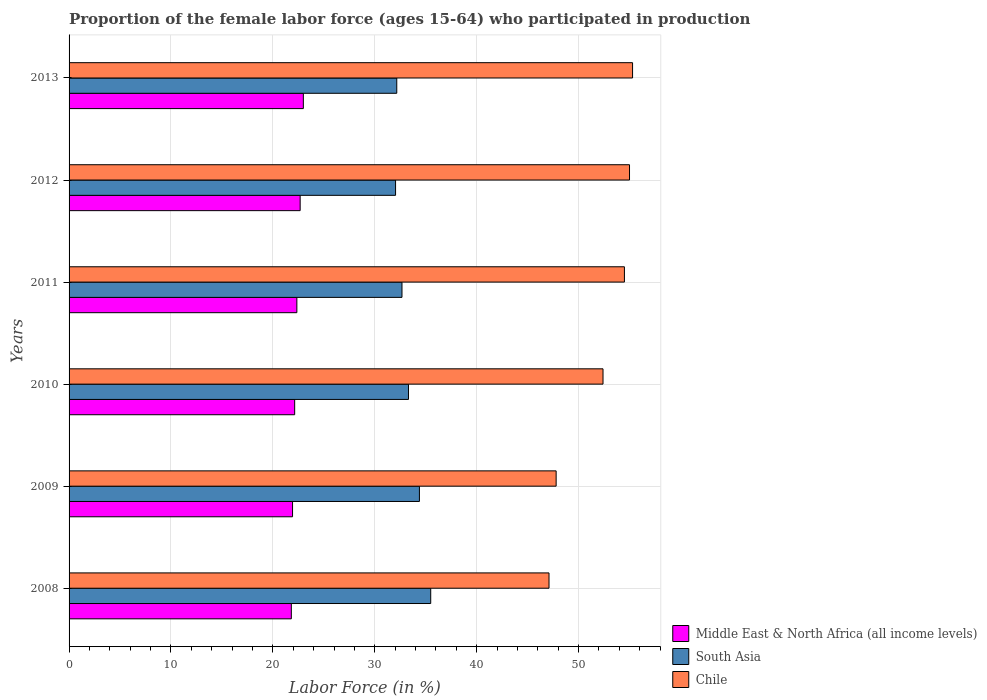How many bars are there on the 6th tick from the bottom?
Give a very brief answer. 3. What is the label of the 5th group of bars from the top?
Your answer should be compact. 2009. What is the proportion of the female labor force who participated in production in South Asia in 2010?
Provide a short and direct response. 33.31. Across all years, what is the maximum proportion of the female labor force who participated in production in South Asia?
Offer a very short reply. 35.49. Across all years, what is the minimum proportion of the female labor force who participated in production in Middle East & North Africa (all income levels)?
Your response must be concise. 21.81. In which year was the proportion of the female labor force who participated in production in Middle East & North Africa (all income levels) minimum?
Give a very brief answer. 2008. What is the total proportion of the female labor force who participated in production in Chile in the graph?
Give a very brief answer. 312.1. What is the difference between the proportion of the female labor force who participated in production in Chile in 2010 and that in 2013?
Give a very brief answer. -2.9. What is the difference between the proportion of the female labor force who participated in production in Middle East & North Africa (all income levels) in 2010 and the proportion of the female labor force who participated in production in Chile in 2013?
Your response must be concise. -33.16. What is the average proportion of the female labor force who participated in production in Middle East & North Africa (all income levels) per year?
Keep it short and to the point. 22.32. In the year 2013, what is the difference between the proportion of the female labor force who participated in production in South Asia and proportion of the female labor force who participated in production in Chile?
Provide a short and direct response. -23.14. What is the ratio of the proportion of the female labor force who participated in production in Middle East & North Africa (all income levels) in 2009 to that in 2010?
Ensure brevity in your answer.  0.99. Is the proportion of the female labor force who participated in production in Chile in 2010 less than that in 2011?
Make the answer very short. Yes. What is the difference between the highest and the second highest proportion of the female labor force who participated in production in Middle East & North Africa (all income levels)?
Your response must be concise. 0.31. What is the difference between the highest and the lowest proportion of the female labor force who participated in production in Middle East & North Africa (all income levels)?
Provide a succinct answer. 1.18. What does the 3rd bar from the top in 2009 represents?
Your answer should be compact. Middle East & North Africa (all income levels). What does the 3rd bar from the bottom in 2013 represents?
Make the answer very short. Chile. Is it the case that in every year, the sum of the proportion of the female labor force who participated in production in South Asia and proportion of the female labor force who participated in production in Middle East & North Africa (all income levels) is greater than the proportion of the female labor force who participated in production in Chile?
Your answer should be very brief. No. Are all the bars in the graph horizontal?
Make the answer very short. Yes. How many years are there in the graph?
Keep it short and to the point. 6. Are the values on the major ticks of X-axis written in scientific E-notation?
Give a very brief answer. No. Does the graph contain grids?
Make the answer very short. Yes. Where does the legend appear in the graph?
Offer a very short reply. Bottom right. How many legend labels are there?
Ensure brevity in your answer.  3. What is the title of the graph?
Your response must be concise. Proportion of the female labor force (ages 15-64) who participated in production. What is the Labor Force (in %) of Middle East & North Africa (all income levels) in 2008?
Give a very brief answer. 21.81. What is the Labor Force (in %) of South Asia in 2008?
Offer a very short reply. 35.49. What is the Labor Force (in %) in Chile in 2008?
Your response must be concise. 47.1. What is the Labor Force (in %) in Middle East & North Africa (all income levels) in 2009?
Make the answer very short. 21.93. What is the Labor Force (in %) in South Asia in 2009?
Make the answer very short. 34.38. What is the Labor Force (in %) in Chile in 2009?
Keep it short and to the point. 47.8. What is the Labor Force (in %) in Middle East & North Africa (all income levels) in 2010?
Ensure brevity in your answer.  22.14. What is the Labor Force (in %) in South Asia in 2010?
Your answer should be very brief. 33.31. What is the Labor Force (in %) in Chile in 2010?
Provide a short and direct response. 52.4. What is the Labor Force (in %) in Middle East & North Africa (all income levels) in 2011?
Provide a short and direct response. 22.35. What is the Labor Force (in %) of South Asia in 2011?
Your answer should be compact. 32.67. What is the Labor Force (in %) in Chile in 2011?
Your answer should be very brief. 54.5. What is the Labor Force (in %) of Middle East & North Africa (all income levels) in 2012?
Your answer should be very brief. 22.68. What is the Labor Force (in %) in South Asia in 2012?
Make the answer very short. 32.04. What is the Labor Force (in %) in Chile in 2012?
Your answer should be compact. 55. What is the Labor Force (in %) in Middle East & North Africa (all income levels) in 2013?
Provide a short and direct response. 22.99. What is the Labor Force (in %) of South Asia in 2013?
Offer a terse response. 32.16. What is the Labor Force (in %) of Chile in 2013?
Offer a terse response. 55.3. Across all years, what is the maximum Labor Force (in %) of Middle East & North Africa (all income levels)?
Offer a very short reply. 22.99. Across all years, what is the maximum Labor Force (in %) in South Asia?
Offer a very short reply. 35.49. Across all years, what is the maximum Labor Force (in %) in Chile?
Your answer should be very brief. 55.3. Across all years, what is the minimum Labor Force (in %) of Middle East & North Africa (all income levels)?
Your answer should be compact. 21.81. Across all years, what is the minimum Labor Force (in %) of South Asia?
Offer a terse response. 32.04. Across all years, what is the minimum Labor Force (in %) of Chile?
Your answer should be compact. 47.1. What is the total Labor Force (in %) in Middle East & North Africa (all income levels) in the graph?
Your answer should be very brief. 133.91. What is the total Labor Force (in %) in South Asia in the graph?
Ensure brevity in your answer.  200.05. What is the total Labor Force (in %) of Chile in the graph?
Your response must be concise. 312.1. What is the difference between the Labor Force (in %) in Middle East & North Africa (all income levels) in 2008 and that in 2009?
Provide a short and direct response. -0.12. What is the difference between the Labor Force (in %) in South Asia in 2008 and that in 2009?
Keep it short and to the point. 1.11. What is the difference between the Labor Force (in %) of Middle East & North Africa (all income levels) in 2008 and that in 2010?
Your response must be concise. -0.33. What is the difference between the Labor Force (in %) in South Asia in 2008 and that in 2010?
Offer a very short reply. 2.18. What is the difference between the Labor Force (in %) of Middle East & North Africa (all income levels) in 2008 and that in 2011?
Your answer should be very brief. -0.54. What is the difference between the Labor Force (in %) in South Asia in 2008 and that in 2011?
Give a very brief answer. 2.82. What is the difference between the Labor Force (in %) of Chile in 2008 and that in 2011?
Keep it short and to the point. -7.4. What is the difference between the Labor Force (in %) in Middle East & North Africa (all income levels) in 2008 and that in 2012?
Give a very brief answer. -0.87. What is the difference between the Labor Force (in %) in South Asia in 2008 and that in 2012?
Your response must be concise. 3.45. What is the difference between the Labor Force (in %) of Middle East & North Africa (all income levels) in 2008 and that in 2013?
Your answer should be compact. -1.18. What is the difference between the Labor Force (in %) of South Asia in 2008 and that in 2013?
Your answer should be compact. 3.33. What is the difference between the Labor Force (in %) of Middle East & North Africa (all income levels) in 2009 and that in 2010?
Offer a very short reply. -0.21. What is the difference between the Labor Force (in %) in South Asia in 2009 and that in 2010?
Offer a terse response. 1.07. What is the difference between the Labor Force (in %) in Middle East & North Africa (all income levels) in 2009 and that in 2011?
Offer a very short reply. -0.42. What is the difference between the Labor Force (in %) in South Asia in 2009 and that in 2011?
Provide a succinct answer. 1.71. What is the difference between the Labor Force (in %) of Middle East & North Africa (all income levels) in 2009 and that in 2012?
Keep it short and to the point. -0.75. What is the difference between the Labor Force (in %) in South Asia in 2009 and that in 2012?
Give a very brief answer. 2.34. What is the difference between the Labor Force (in %) in Middle East & North Africa (all income levels) in 2009 and that in 2013?
Make the answer very short. -1.06. What is the difference between the Labor Force (in %) of South Asia in 2009 and that in 2013?
Your answer should be very brief. 2.22. What is the difference between the Labor Force (in %) in Middle East & North Africa (all income levels) in 2010 and that in 2011?
Your answer should be compact. -0.21. What is the difference between the Labor Force (in %) of South Asia in 2010 and that in 2011?
Offer a terse response. 0.64. What is the difference between the Labor Force (in %) of Chile in 2010 and that in 2011?
Provide a short and direct response. -2.1. What is the difference between the Labor Force (in %) of Middle East & North Africa (all income levels) in 2010 and that in 2012?
Provide a short and direct response. -0.54. What is the difference between the Labor Force (in %) of South Asia in 2010 and that in 2012?
Ensure brevity in your answer.  1.27. What is the difference between the Labor Force (in %) of Middle East & North Africa (all income levels) in 2010 and that in 2013?
Provide a succinct answer. -0.85. What is the difference between the Labor Force (in %) of South Asia in 2010 and that in 2013?
Your response must be concise. 1.15. What is the difference between the Labor Force (in %) of Chile in 2010 and that in 2013?
Offer a terse response. -2.9. What is the difference between the Labor Force (in %) of Middle East & North Africa (all income levels) in 2011 and that in 2012?
Your answer should be compact. -0.32. What is the difference between the Labor Force (in %) of South Asia in 2011 and that in 2012?
Provide a short and direct response. 0.63. What is the difference between the Labor Force (in %) of Chile in 2011 and that in 2012?
Offer a very short reply. -0.5. What is the difference between the Labor Force (in %) in Middle East & North Africa (all income levels) in 2011 and that in 2013?
Keep it short and to the point. -0.64. What is the difference between the Labor Force (in %) in South Asia in 2011 and that in 2013?
Provide a short and direct response. 0.51. What is the difference between the Labor Force (in %) in Chile in 2011 and that in 2013?
Offer a very short reply. -0.8. What is the difference between the Labor Force (in %) of Middle East & North Africa (all income levels) in 2012 and that in 2013?
Keep it short and to the point. -0.31. What is the difference between the Labor Force (in %) of South Asia in 2012 and that in 2013?
Your answer should be very brief. -0.12. What is the difference between the Labor Force (in %) of Chile in 2012 and that in 2013?
Make the answer very short. -0.3. What is the difference between the Labor Force (in %) of Middle East & North Africa (all income levels) in 2008 and the Labor Force (in %) of South Asia in 2009?
Make the answer very short. -12.57. What is the difference between the Labor Force (in %) in Middle East & North Africa (all income levels) in 2008 and the Labor Force (in %) in Chile in 2009?
Your response must be concise. -25.99. What is the difference between the Labor Force (in %) of South Asia in 2008 and the Labor Force (in %) of Chile in 2009?
Your response must be concise. -12.31. What is the difference between the Labor Force (in %) in Middle East & North Africa (all income levels) in 2008 and the Labor Force (in %) in South Asia in 2010?
Make the answer very short. -11.5. What is the difference between the Labor Force (in %) of Middle East & North Africa (all income levels) in 2008 and the Labor Force (in %) of Chile in 2010?
Make the answer very short. -30.59. What is the difference between the Labor Force (in %) in South Asia in 2008 and the Labor Force (in %) in Chile in 2010?
Make the answer very short. -16.91. What is the difference between the Labor Force (in %) of Middle East & North Africa (all income levels) in 2008 and the Labor Force (in %) of South Asia in 2011?
Make the answer very short. -10.86. What is the difference between the Labor Force (in %) in Middle East & North Africa (all income levels) in 2008 and the Labor Force (in %) in Chile in 2011?
Ensure brevity in your answer.  -32.69. What is the difference between the Labor Force (in %) of South Asia in 2008 and the Labor Force (in %) of Chile in 2011?
Provide a succinct answer. -19.01. What is the difference between the Labor Force (in %) in Middle East & North Africa (all income levels) in 2008 and the Labor Force (in %) in South Asia in 2012?
Your response must be concise. -10.23. What is the difference between the Labor Force (in %) of Middle East & North Africa (all income levels) in 2008 and the Labor Force (in %) of Chile in 2012?
Ensure brevity in your answer.  -33.19. What is the difference between the Labor Force (in %) of South Asia in 2008 and the Labor Force (in %) of Chile in 2012?
Provide a succinct answer. -19.51. What is the difference between the Labor Force (in %) in Middle East & North Africa (all income levels) in 2008 and the Labor Force (in %) in South Asia in 2013?
Your answer should be compact. -10.35. What is the difference between the Labor Force (in %) in Middle East & North Africa (all income levels) in 2008 and the Labor Force (in %) in Chile in 2013?
Provide a short and direct response. -33.49. What is the difference between the Labor Force (in %) of South Asia in 2008 and the Labor Force (in %) of Chile in 2013?
Keep it short and to the point. -19.81. What is the difference between the Labor Force (in %) in Middle East & North Africa (all income levels) in 2009 and the Labor Force (in %) in South Asia in 2010?
Provide a short and direct response. -11.38. What is the difference between the Labor Force (in %) in Middle East & North Africa (all income levels) in 2009 and the Labor Force (in %) in Chile in 2010?
Your answer should be very brief. -30.47. What is the difference between the Labor Force (in %) in South Asia in 2009 and the Labor Force (in %) in Chile in 2010?
Make the answer very short. -18.02. What is the difference between the Labor Force (in %) of Middle East & North Africa (all income levels) in 2009 and the Labor Force (in %) of South Asia in 2011?
Your answer should be compact. -10.74. What is the difference between the Labor Force (in %) in Middle East & North Africa (all income levels) in 2009 and the Labor Force (in %) in Chile in 2011?
Provide a succinct answer. -32.57. What is the difference between the Labor Force (in %) in South Asia in 2009 and the Labor Force (in %) in Chile in 2011?
Provide a short and direct response. -20.12. What is the difference between the Labor Force (in %) of Middle East & North Africa (all income levels) in 2009 and the Labor Force (in %) of South Asia in 2012?
Your answer should be compact. -10.11. What is the difference between the Labor Force (in %) in Middle East & North Africa (all income levels) in 2009 and the Labor Force (in %) in Chile in 2012?
Your answer should be compact. -33.07. What is the difference between the Labor Force (in %) of South Asia in 2009 and the Labor Force (in %) of Chile in 2012?
Give a very brief answer. -20.62. What is the difference between the Labor Force (in %) in Middle East & North Africa (all income levels) in 2009 and the Labor Force (in %) in South Asia in 2013?
Give a very brief answer. -10.23. What is the difference between the Labor Force (in %) in Middle East & North Africa (all income levels) in 2009 and the Labor Force (in %) in Chile in 2013?
Offer a terse response. -33.37. What is the difference between the Labor Force (in %) in South Asia in 2009 and the Labor Force (in %) in Chile in 2013?
Provide a succinct answer. -20.92. What is the difference between the Labor Force (in %) of Middle East & North Africa (all income levels) in 2010 and the Labor Force (in %) of South Asia in 2011?
Give a very brief answer. -10.53. What is the difference between the Labor Force (in %) in Middle East & North Africa (all income levels) in 2010 and the Labor Force (in %) in Chile in 2011?
Offer a terse response. -32.36. What is the difference between the Labor Force (in %) of South Asia in 2010 and the Labor Force (in %) of Chile in 2011?
Provide a succinct answer. -21.19. What is the difference between the Labor Force (in %) of Middle East & North Africa (all income levels) in 2010 and the Labor Force (in %) of South Asia in 2012?
Provide a succinct answer. -9.9. What is the difference between the Labor Force (in %) of Middle East & North Africa (all income levels) in 2010 and the Labor Force (in %) of Chile in 2012?
Offer a very short reply. -32.86. What is the difference between the Labor Force (in %) in South Asia in 2010 and the Labor Force (in %) in Chile in 2012?
Provide a succinct answer. -21.69. What is the difference between the Labor Force (in %) of Middle East & North Africa (all income levels) in 2010 and the Labor Force (in %) of South Asia in 2013?
Keep it short and to the point. -10.02. What is the difference between the Labor Force (in %) of Middle East & North Africa (all income levels) in 2010 and the Labor Force (in %) of Chile in 2013?
Provide a short and direct response. -33.16. What is the difference between the Labor Force (in %) in South Asia in 2010 and the Labor Force (in %) in Chile in 2013?
Your answer should be compact. -21.99. What is the difference between the Labor Force (in %) of Middle East & North Africa (all income levels) in 2011 and the Labor Force (in %) of South Asia in 2012?
Keep it short and to the point. -9.69. What is the difference between the Labor Force (in %) of Middle East & North Africa (all income levels) in 2011 and the Labor Force (in %) of Chile in 2012?
Provide a succinct answer. -32.65. What is the difference between the Labor Force (in %) of South Asia in 2011 and the Labor Force (in %) of Chile in 2012?
Your answer should be very brief. -22.33. What is the difference between the Labor Force (in %) of Middle East & North Africa (all income levels) in 2011 and the Labor Force (in %) of South Asia in 2013?
Give a very brief answer. -9.81. What is the difference between the Labor Force (in %) of Middle East & North Africa (all income levels) in 2011 and the Labor Force (in %) of Chile in 2013?
Ensure brevity in your answer.  -32.95. What is the difference between the Labor Force (in %) of South Asia in 2011 and the Labor Force (in %) of Chile in 2013?
Your answer should be compact. -22.63. What is the difference between the Labor Force (in %) of Middle East & North Africa (all income levels) in 2012 and the Labor Force (in %) of South Asia in 2013?
Give a very brief answer. -9.48. What is the difference between the Labor Force (in %) of Middle East & North Africa (all income levels) in 2012 and the Labor Force (in %) of Chile in 2013?
Offer a terse response. -32.62. What is the difference between the Labor Force (in %) in South Asia in 2012 and the Labor Force (in %) in Chile in 2013?
Your answer should be very brief. -23.26. What is the average Labor Force (in %) of Middle East & North Africa (all income levels) per year?
Provide a succinct answer. 22.32. What is the average Labor Force (in %) in South Asia per year?
Your answer should be very brief. 33.34. What is the average Labor Force (in %) of Chile per year?
Your response must be concise. 52.02. In the year 2008, what is the difference between the Labor Force (in %) in Middle East & North Africa (all income levels) and Labor Force (in %) in South Asia?
Your response must be concise. -13.68. In the year 2008, what is the difference between the Labor Force (in %) in Middle East & North Africa (all income levels) and Labor Force (in %) in Chile?
Provide a succinct answer. -25.29. In the year 2008, what is the difference between the Labor Force (in %) of South Asia and Labor Force (in %) of Chile?
Offer a terse response. -11.61. In the year 2009, what is the difference between the Labor Force (in %) of Middle East & North Africa (all income levels) and Labor Force (in %) of South Asia?
Keep it short and to the point. -12.45. In the year 2009, what is the difference between the Labor Force (in %) in Middle East & North Africa (all income levels) and Labor Force (in %) in Chile?
Give a very brief answer. -25.87. In the year 2009, what is the difference between the Labor Force (in %) in South Asia and Labor Force (in %) in Chile?
Your answer should be compact. -13.42. In the year 2010, what is the difference between the Labor Force (in %) in Middle East & North Africa (all income levels) and Labor Force (in %) in South Asia?
Keep it short and to the point. -11.17. In the year 2010, what is the difference between the Labor Force (in %) in Middle East & North Africa (all income levels) and Labor Force (in %) in Chile?
Give a very brief answer. -30.26. In the year 2010, what is the difference between the Labor Force (in %) in South Asia and Labor Force (in %) in Chile?
Offer a very short reply. -19.09. In the year 2011, what is the difference between the Labor Force (in %) in Middle East & North Africa (all income levels) and Labor Force (in %) in South Asia?
Provide a short and direct response. -10.32. In the year 2011, what is the difference between the Labor Force (in %) of Middle East & North Africa (all income levels) and Labor Force (in %) of Chile?
Make the answer very short. -32.15. In the year 2011, what is the difference between the Labor Force (in %) of South Asia and Labor Force (in %) of Chile?
Keep it short and to the point. -21.83. In the year 2012, what is the difference between the Labor Force (in %) of Middle East & North Africa (all income levels) and Labor Force (in %) of South Asia?
Your response must be concise. -9.36. In the year 2012, what is the difference between the Labor Force (in %) of Middle East & North Africa (all income levels) and Labor Force (in %) of Chile?
Offer a terse response. -32.32. In the year 2012, what is the difference between the Labor Force (in %) in South Asia and Labor Force (in %) in Chile?
Make the answer very short. -22.96. In the year 2013, what is the difference between the Labor Force (in %) in Middle East & North Africa (all income levels) and Labor Force (in %) in South Asia?
Your answer should be compact. -9.17. In the year 2013, what is the difference between the Labor Force (in %) in Middle East & North Africa (all income levels) and Labor Force (in %) in Chile?
Provide a short and direct response. -32.31. In the year 2013, what is the difference between the Labor Force (in %) in South Asia and Labor Force (in %) in Chile?
Make the answer very short. -23.14. What is the ratio of the Labor Force (in %) of Middle East & North Africa (all income levels) in 2008 to that in 2009?
Your response must be concise. 0.99. What is the ratio of the Labor Force (in %) in South Asia in 2008 to that in 2009?
Your response must be concise. 1.03. What is the ratio of the Labor Force (in %) in Chile in 2008 to that in 2009?
Keep it short and to the point. 0.99. What is the ratio of the Labor Force (in %) of Middle East & North Africa (all income levels) in 2008 to that in 2010?
Offer a terse response. 0.99. What is the ratio of the Labor Force (in %) in South Asia in 2008 to that in 2010?
Ensure brevity in your answer.  1.07. What is the ratio of the Labor Force (in %) in Chile in 2008 to that in 2010?
Offer a very short reply. 0.9. What is the ratio of the Labor Force (in %) in Middle East & North Africa (all income levels) in 2008 to that in 2011?
Your answer should be very brief. 0.98. What is the ratio of the Labor Force (in %) in South Asia in 2008 to that in 2011?
Keep it short and to the point. 1.09. What is the ratio of the Labor Force (in %) of Chile in 2008 to that in 2011?
Offer a terse response. 0.86. What is the ratio of the Labor Force (in %) of Middle East & North Africa (all income levels) in 2008 to that in 2012?
Offer a terse response. 0.96. What is the ratio of the Labor Force (in %) in South Asia in 2008 to that in 2012?
Make the answer very short. 1.11. What is the ratio of the Labor Force (in %) in Chile in 2008 to that in 2012?
Keep it short and to the point. 0.86. What is the ratio of the Labor Force (in %) of Middle East & North Africa (all income levels) in 2008 to that in 2013?
Your response must be concise. 0.95. What is the ratio of the Labor Force (in %) of South Asia in 2008 to that in 2013?
Ensure brevity in your answer.  1.1. What is the ratio of the Labor Force (in %) of Chile in 2008 to that in 2013?
Keep it short and to the point. 0.85. What is the ratio of the Labor Force (in %) in Middle East & North Africa (all income levels) in 2009 to that in 2010?
Ensure brevity in your answer.  0.99. What is the ratio of the Labor Force (in %) of South Asia in 2009 to that in 2010?
Offer a terse response. 1.03. What is the ratio of the Labor Force (in %) in Chile in 2009 to that in 2010?
Your answer should be compact. 0.91. What is the ratio of the Labor Force (in %) in Middle East & North Africa (all income levels) in 2009 to that in 2011?
Keep it short and to the point. 0.98. What is the ratio of the Labor Force (in %) of South Asia in 2009 to that in 2011?
Provide a succinct answer. 1.05. What is the ratio of the Labor Force (in %) of Chile in 2009 to that in 2011?
Your answer should be very brief. 0.88. What is the ratio of the Labor Force (in %) in South Asia in 2009 to that in 2012?
Your answer should be very brief. 1.07. What is the ratio of the Labor Force (in %) of Chile in 2009 to that in 2012?
Offer a terse response. 0.87. What is the ratio of the Labor Force (in %) in Middle East & North Africa (all income levels) in 2009 to that in 2013?
Keep it short and to the point. 0.95. What is the ratio of the Labor Force (in %) in South Asia in 2009 to that in 2013?
Your answer should be very brief. 1.07. What is the ratio of the Labor Force (in %) in Chile in 2009 to that in 2013?
Offer a very short reply. 0.86. What is the ratio of the Labor Force (in %) in Middle East & North Africa (all income levels) in 2010 to that in 2011?
Provide a succinct answer. 0.99. What is the ratio of the Labor Force (in %) in South Asia in 2010 to that in 2011?
Your answer should be compact. 1.02. What is the ratio of the Labor Force (in %) of Chile in 2010 to that in 2011?
Offer a very short reply. 0.96. What is the ratio of the Labor Force (in %) of Middle East & North Africa (all income levels) in 2010 to that in 2012?
Provide a succinct answer. 0.98. What is the ratio of the Labor Force (in %) in South Asia in 2010 to that in 2012?
Ensure brevity in your answer.  1.04. What is the ratio of the Labor Force (in %) in Chile in 2010 to that in 2012?
Provide a succinct answer. 0.95. What is the ratio of the Labor Force (in %) in Middle East & North Africa (all income levels) in 2010 to that in 2013?
Make the answer very short. 0.96. What is the ratio of the Labor Force (in %) in South Asia in 2010 to that in 2013?
Your answer should be compact. 1.04. What is the ratio of the Labor Force (in %) of Chile in 2010 to that in 2013?
Offer a very short reply. 0.95. What is the ratio of the Labor Force (in %) of Middle East & North Africa (all income levels) in 2011 to that in 2012?
Provide a succinct answer. 0.99. What is the ratio of the Labor Force (in %) in South Asia in 2011 to that in 2012?
Provide a succinct answer. 1.02. What is the ratio of the Labor Force (in %) of Chile in 2011 to that in 2012?
Ensure brevity in your answer.  0.99. What is the ratio of the Labor Force (in %) of Middle East & North Africa (all income levels) in 2011 to that in 2013?
Provide a succinct answer. 0.97. What is the ratio of the Labor Force (in %) of South Asia in 2011 to that in 2013?
Provide a succinct answer. 1.02. What is the ratio of the Labor Force (in %) of Chile in 2011 to that in 2013?
Your response must be concise. 0.99. What is the ratio of the Labor Force (in %) of Middle East & North Africa (all income levels) in 2012 to that in 2013?
Provide a succinct answer. 0.99. What is the ratio of the Labor Force (in %) of Chile in 2012 to that in 2013?
Provide a short and direct response. 0.99. What is the difference between the highest and the second highest Labor Force (in %) in Middle East & North Africa (all income levels)?
Provide a succinct answer. 0.31. What is the difference between the highest and the second highest Labor Force (in %) in South Asia?
Provide a short and direct response. 1.11. What is the difference between the highest and the lowest Labor Force (in %) in Middle East & North Africa (all income levels)?
Make the answer very short. 1.18. What is the difference between the highest and the lowest Labor Force (in %) of South Asia?
Your answer should be very brief. 3.45. What is the difference between the highest and the lowest Labor Force (in %) in Chile?
Offer a terse response. 8.2. 